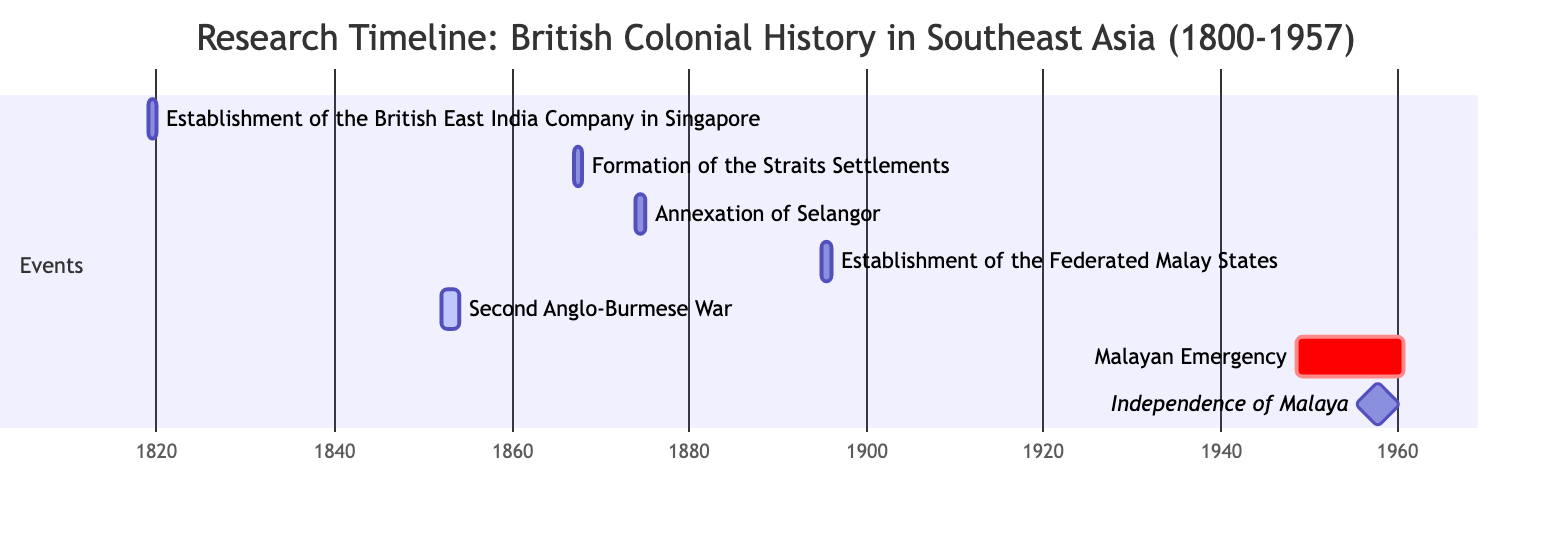What is the duration of the Second Anglo-Burmese War? The Second Anglo-Burmese War is represented in the Gantt chart as lasting from 1852 to 1853. The duration can be calculated by finding the difference between the end year (1853) and the start year (1852), which gives us a total of 1 year.
Answer: 1 year Which event occurs last in the timeline? By analyzing the Gantt chart from the earliest to the latest date, the Independence of Malaya is marked as occurring on August 31, 1957, which is the latest date in the events listed.
Answer: Independence of Malaya How many events are listed in the diagram? The Gantt chart contains a specific number of events represented, which can be counted directly from the entries listed, resulting in a total of 6 events.
Answer: 6 events Which event has the earliest start date? By examining the start dates of all events listed, we find that the establishment of the British East India Company in Singapore has the earliest start date of January 1, 1819.
Answer: Establishment of the British East India Company in Singapore What is the significant milestone indicated in the timeline? The diagram marks the Independence of Malaya as a milestone event, which is a noteworthy point in the timeline due to its historical significance for the region, stated as occurring on August 31, 1957.
Answer: Independence of Malaya For how many years did the Malayan Emergency last? The Malayan Emergency spans from June 1, 1948, to July 31, 1960. To find the duration, we calculate the difference between the end year (1960) and start year (1948), which totals 12 years, plus the months gives a total of 12 years and around 2 months.
Answer: 12 years Which event has overlapping time periods with the Malayan Emergency? The Malayan Emergency timeline indicates from 1948 to 1960, and no other event overlaps during this period, hence the answer is none, as only one event is active.
Answer: None What is the relationship between the Formation of the Straits Settlements and the Annexation of Selangor? Analyzing the Gantt chart, the Formation of the Straits Settlements occurs in 1867 and the Annexation of Selangor follows in 1874. The relationship shows that these events are sequential, with the Formation of the Straits Settlements occurring before the Annexation of Selangor.
Answer: Sequential What year did the Establishment of the Federated Malay States occur? The event is clearly marked within the Gantt chart as happening in the year 1895, which can be directly read from the diagram.
Answer: 1895 